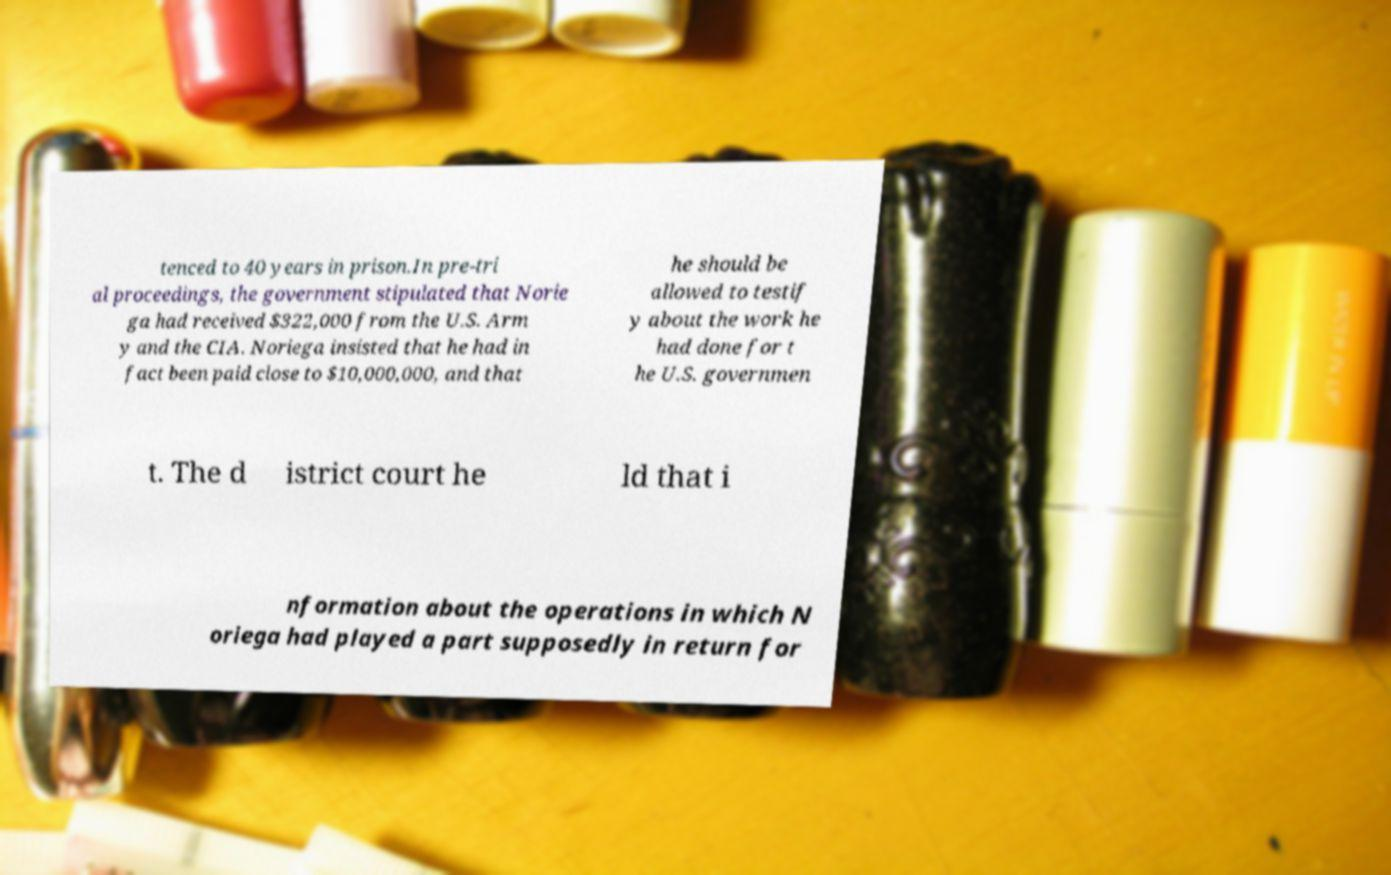Could you assist in decoding the text presented in this image and type it out clearly? tenced to 40 years in prison.In pre-tri al proceedings, the government stipulated that Norie ga had received $322,000 from the U.S. Arm y and the CIA. Noriega insisted that he had in fact been paid close to $10,000,000, and that he should be allowed to testif y about the work he had done for t he U.S. governmen t. The d istrict court he ld that i nformation about the operations in which N oriega had played a part supposedly in return for 